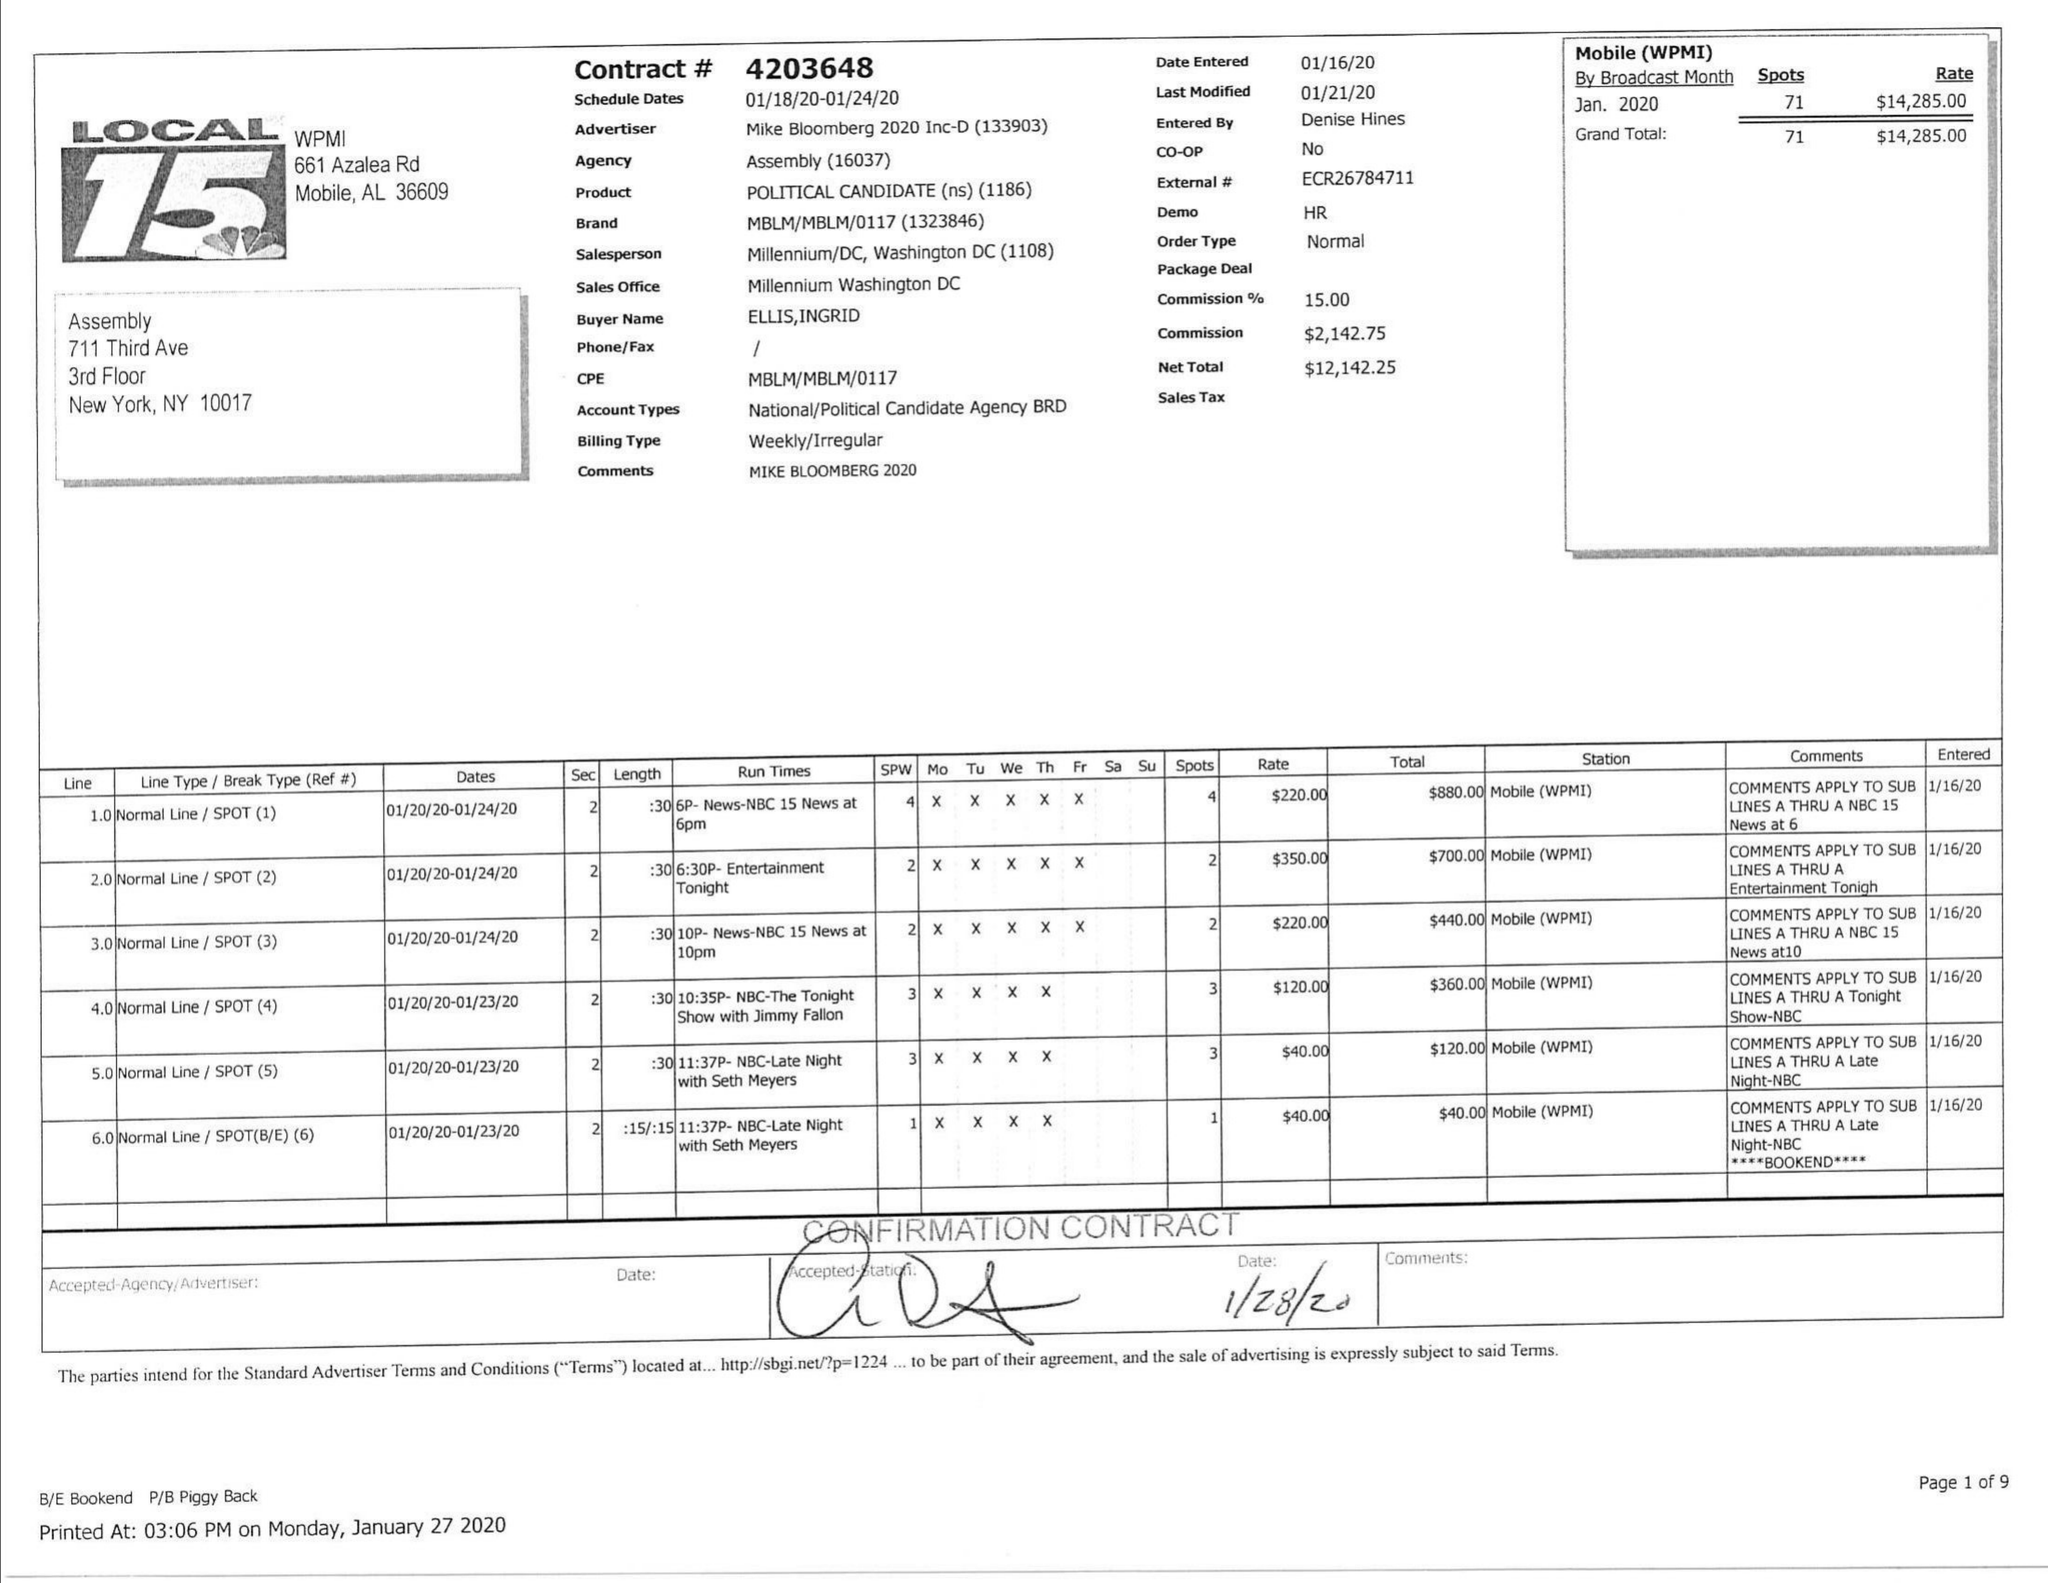What is the value for the flight_to?
Answer the question using a single word or phrase. 01/24/20 